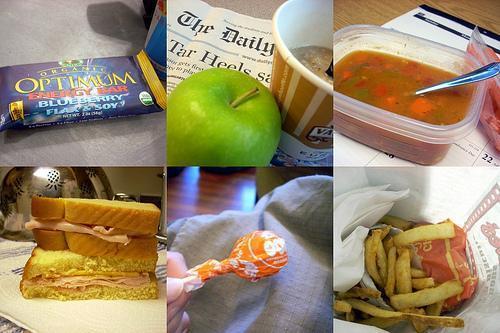How many fruits are in the images?
Give a very brief answer. 1. How many of the train doors are green?
Give a very brief answer. 0. 